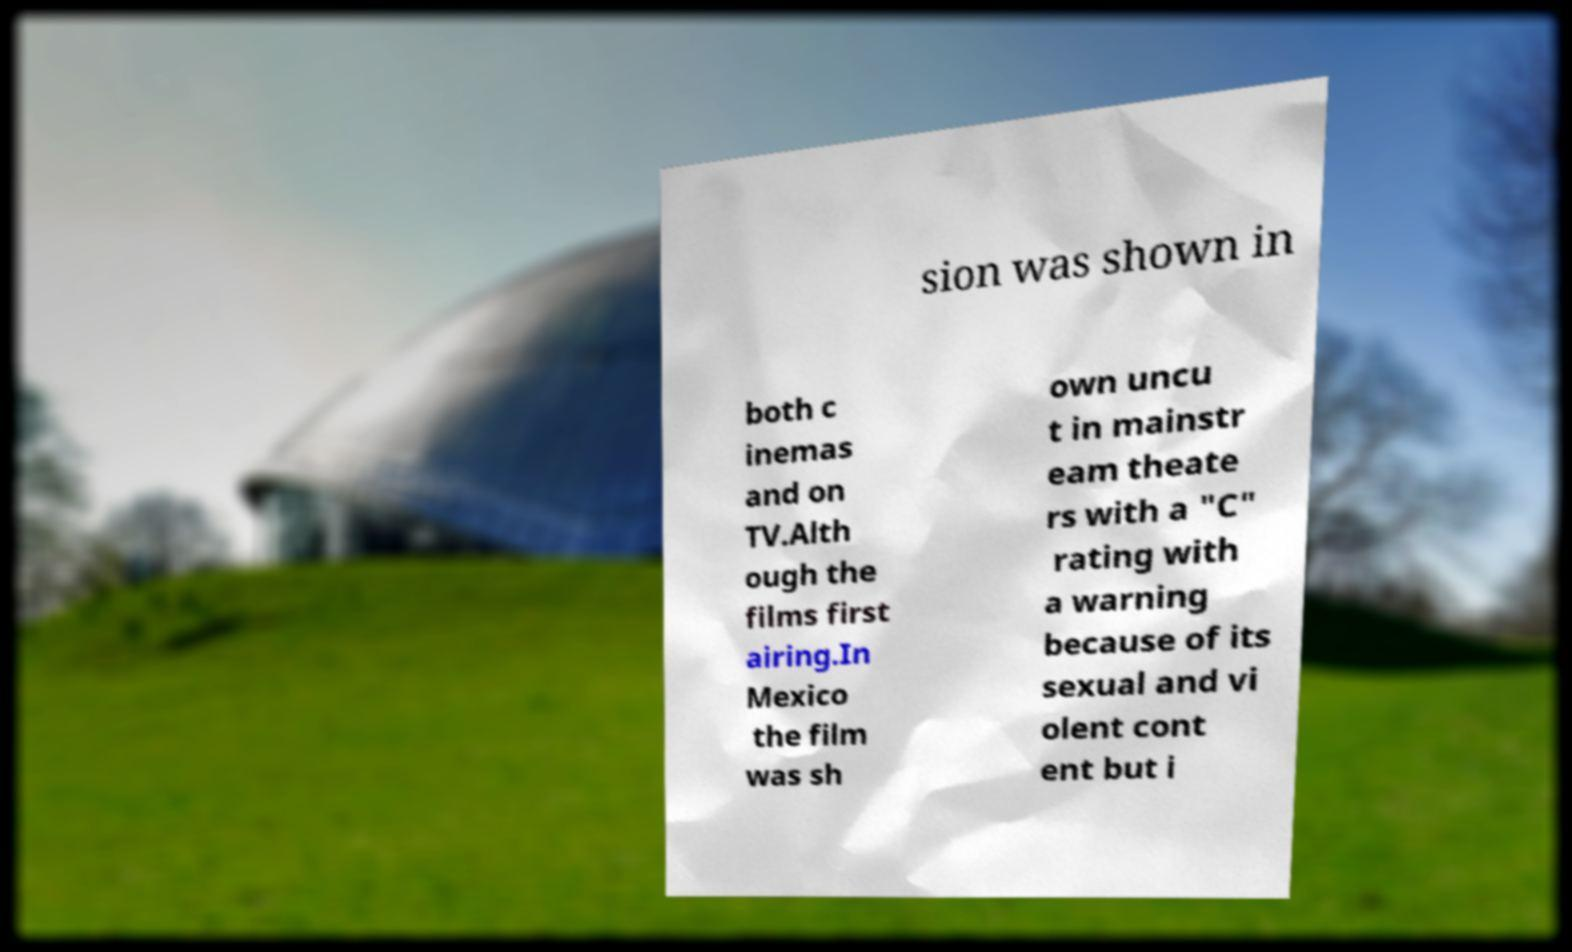Could you extract and type out the text from this image? sion was shown in both c inemas and on TV.Alth ough the films first airing.In Mexico the film was sh own uncu t in mainstr eam theate rs with a "C" rating with a warning because of its sexual and vi olent cont ent but i 